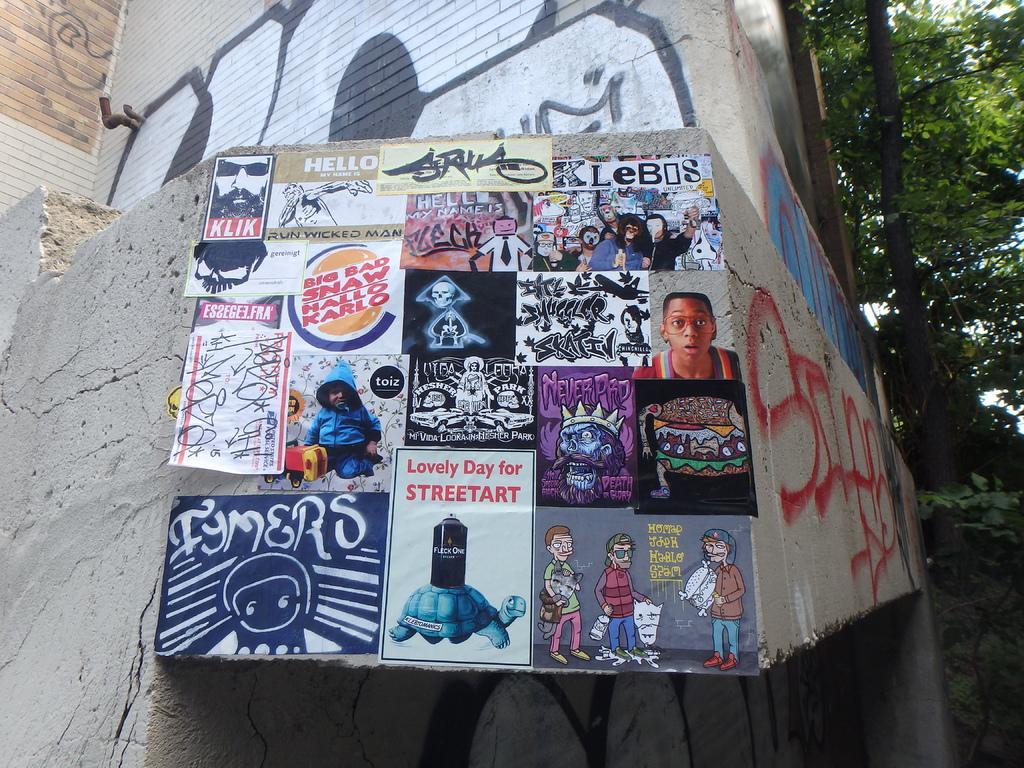In one or two sentences, can you explain what this image depicts? In this image there is a building. On the wall there are many posters. In the background there are trees. 